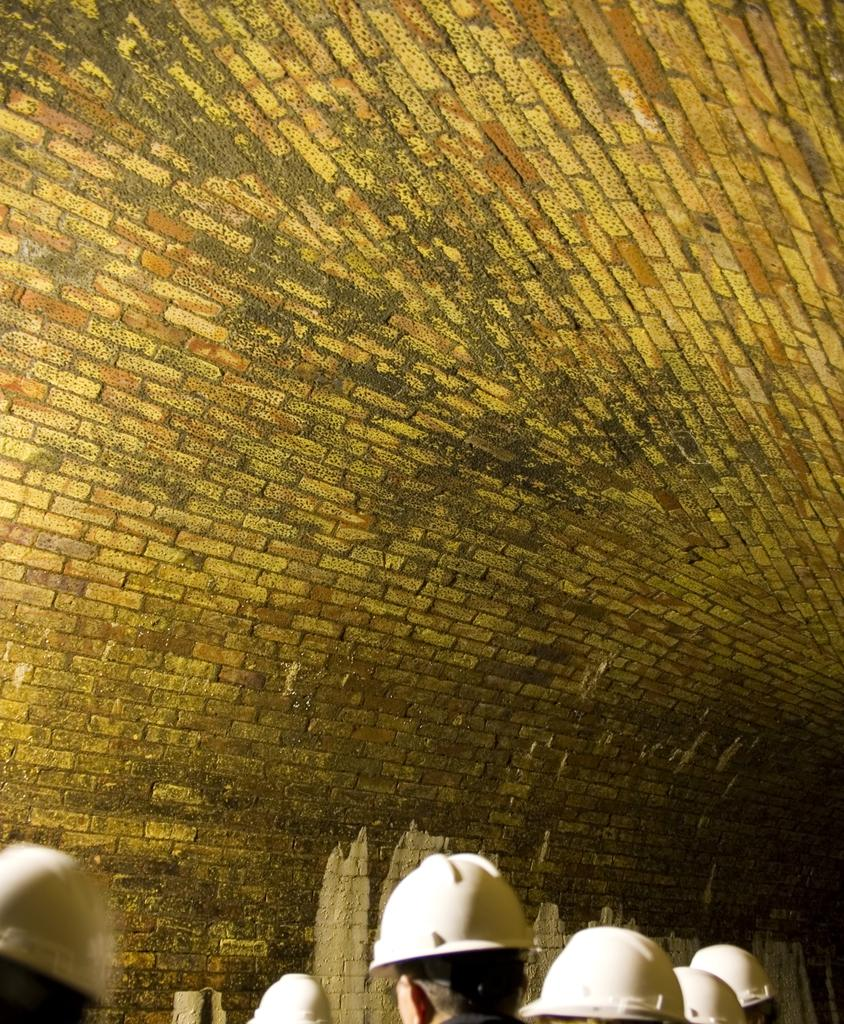What are the people in the image wearing on their heads? The people in the image are wearing helmets. What can be seen in the background of the image? There is a wall visible in the image. What type of cake is being served at the event in the image? There is no cake or event present in the image; it features people wearing helmets and a wall in the background. 